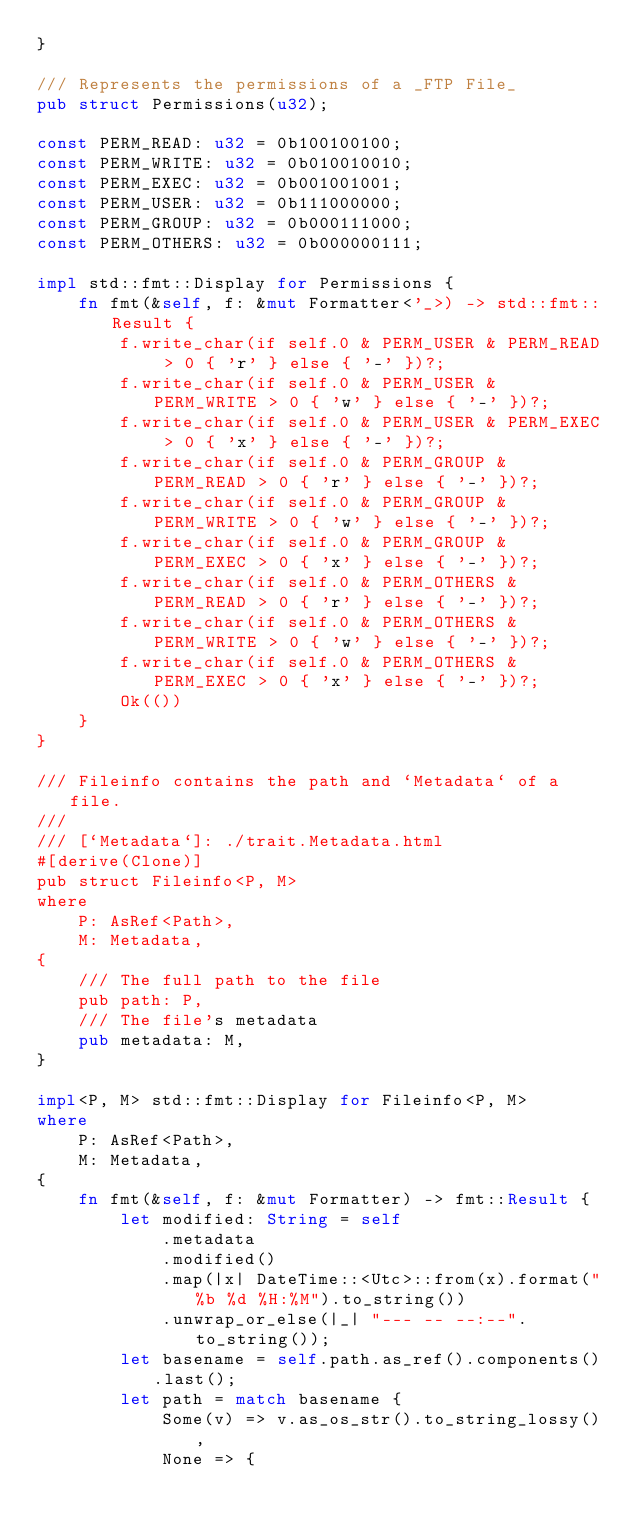Convert code to text. <code><loc_0><loc_0><loc_500><loc_500><_Rust_>}

/// Represents the permissions of a _FTP File_
pub struct Permissions(u32);

const PERM_READ: u32 = 0b100100100;
const PERM_WRITE: u32 = 0b010010010;
const PERM_EXEC: u32 = 0b001001001;
const PERM_USER: u32 = 0b111000000;
const PERM_GROUP: u32 = 0b000111000;
const PERM_OTHERS: u32 = 0b000000111;

impl std::fmt::Display for Permissions {
    fn fmt(&self, f: &mut Formatter<'_>) -> std::fmt::Result {
        f.write_char(if self.0 & PERM_USER & PERM_READ > 0 { 'r' } else { '-' })?;
        f.write_char(if self.0 & PERM_USER & PERM_WRITE > 0 { 'w' } else { '-' })?;
        f.write_char(if self.0 & PERM_USER & PERM_EXEC > 0 { 'x' } else { '-' })?;
        f.write_char(if self.0 & PERM_GROUP & PERM_READ > 0 { 'r' } else { '-' })?;
        f.write_char(if self.0 & PERM_GROUP & PERM_WRITE > 0 { 'w' } else { '-' })?;
        f.write_char(if self.0 & PERM_GROUP & PERM_EXEC > 0 { 'x' } else { '-' })?;
        f.write_char(if self.0 & PERM_OTHERS & PERM_READ > 0 { 'r' } else { '-' })?;
        f.write_char(if self.0 & PERM_OTHERS & PERM_WRITE > 0 { 'w' } else { '-' })?;
        f.write_char(if self.0 & PERM_OTHERS & PERM_EXEC > 0 { 'x' } else { '-' })?;
        Ok(())
    }
}

/// Fileinfo contains the path and `Metadata` of a file.
///
/// [`Metadata`]: ./trait.Metadata.html
#[derive(Clone)]
pub struct Fileinfo<P, M>
where
    P: AsRef<Path>,
    M: Metadata,
{
    /// The full path to the file
    pub path: P,
    /// The file's metadata
    pub metadata: M,
}

impl<P, M> std::fmt::Display for Fileinfo<P, M>
where
    P: AsRef<Path>,
    M: Metadata,
{
    fn fmt(&self, f: &mut Formatter) -> fmt::Result {
        let modified: String = self
            .metadata
            .modified()
            .map(|x| DateTime::<Utc>::from(x).format("%b %d %H:%M").to_string())
            .unwrap_or_else(|_| "--- -- --:--".to_string());
        let basename = self.path.as_ref().components().last();
        let path = match basename {
            Some(v) => v.as_os_str().to_string_lossy(),
            None => {</code> 